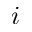<formula> <loc_0><loc_0><loc_500><loc_500>i</formula> 